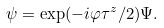<formula> <loc_0><loc_0><loc_500><loc_500>\psi = \exp ( - i \varphi \tau ^ { z } / 2 ) \Psi .</formula> 